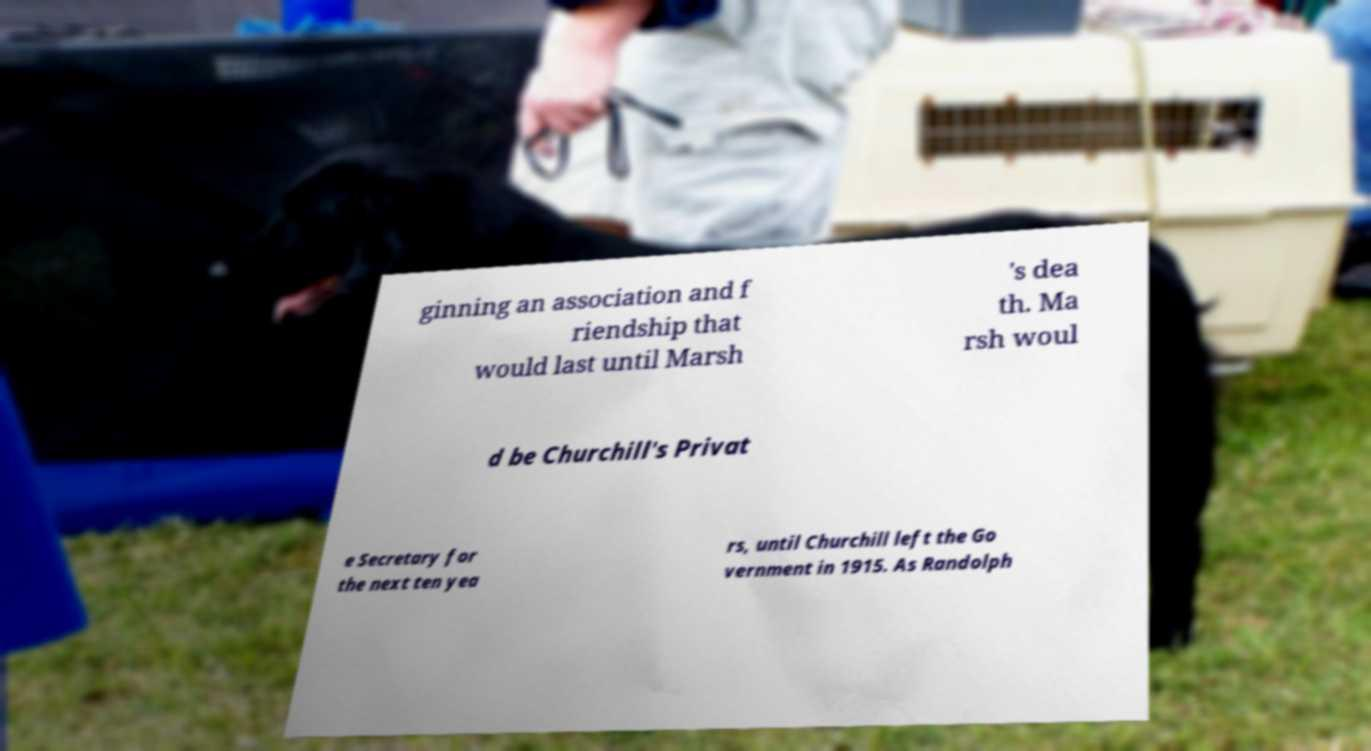Could you extract and type out the text from this image? ginning an association and f riendship that would last until Marsh 's dea th. Ma rsh woul d be Churchill's Privat e Secretary for the next ten yea rs, until Churchill left the Go vernment in 1915. As Randolph 